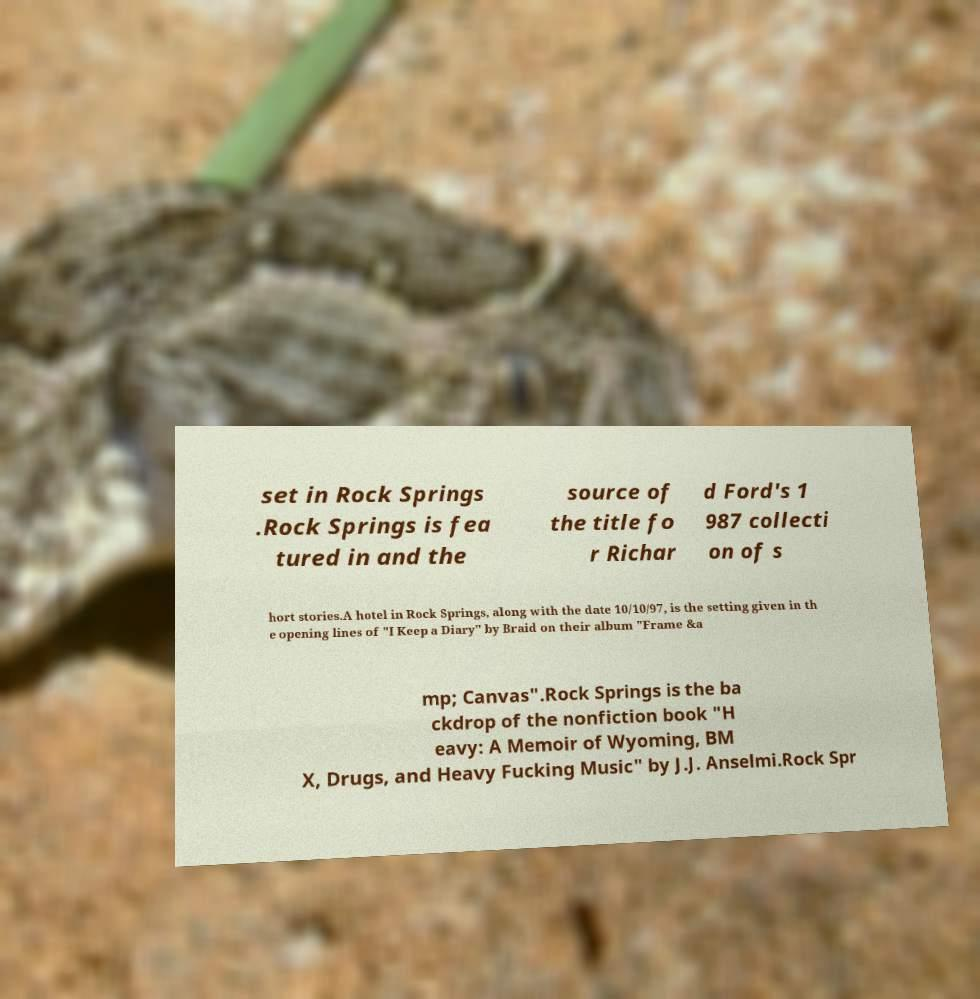Can you accurately transcribe the text from the provided image for me? set in Rock Springs .Rock Springs is fea tured in and the source of the title fo r Richar d Ford's 1 987 collecti on of s hort stories.A hotel in Rock Springs, along with the date 10/10/97, is the setting given in th e opening lines of "I Keep a Diary" by Braid on their album "Frame &a mp; Canvas".Rock Springs is the ba ckdrop of the nonfiction book "H eavy: A Memoir of Wyoming, BM X, Drugs, and Heavy Fucking Music" by J.J. Anselmi.Rock Spr 